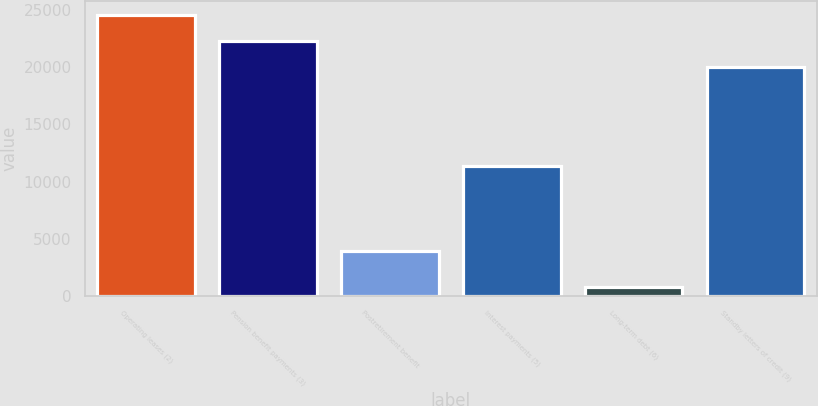Convert chart. <chart><loc_0><loc_0><loc_500><loc_500><bar_chart><fcel>Operating leases (2)<fcel>Pension benefit payments (3)<fcel>Postretirement benefit<fcel>Interest payments (5)<fcel>Long-term debt (6)<fcel>Standby letters of credit (9)<nl><fcel>24591.4<fcel>22306.7<fcel>3900<fcel>11328<fcel>740<fcel>20022<nl></chart> 